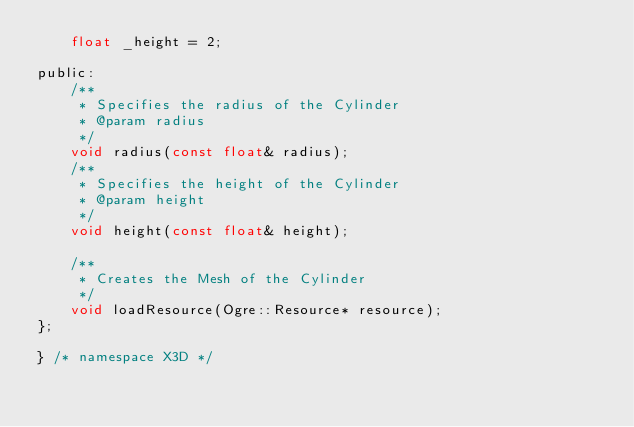Convert code to text. <code><loc_0><loc_0><loc_500><loc_500><_C_>    float _height = 2;

public:
    /**
     * Specifies the radius of the Cylinder
     * @param radius
     */
    void radius(const float& radius);
    /**
     * Specifies the height of the Cylinder
     * @param height
     */
    void height(const float& height);

	/**
	 * Creates the Mesh of the Cylinder
	 */
    void loadResource(Ogre::Resource* resource);
};

} /* namespace X3D */
</code> 